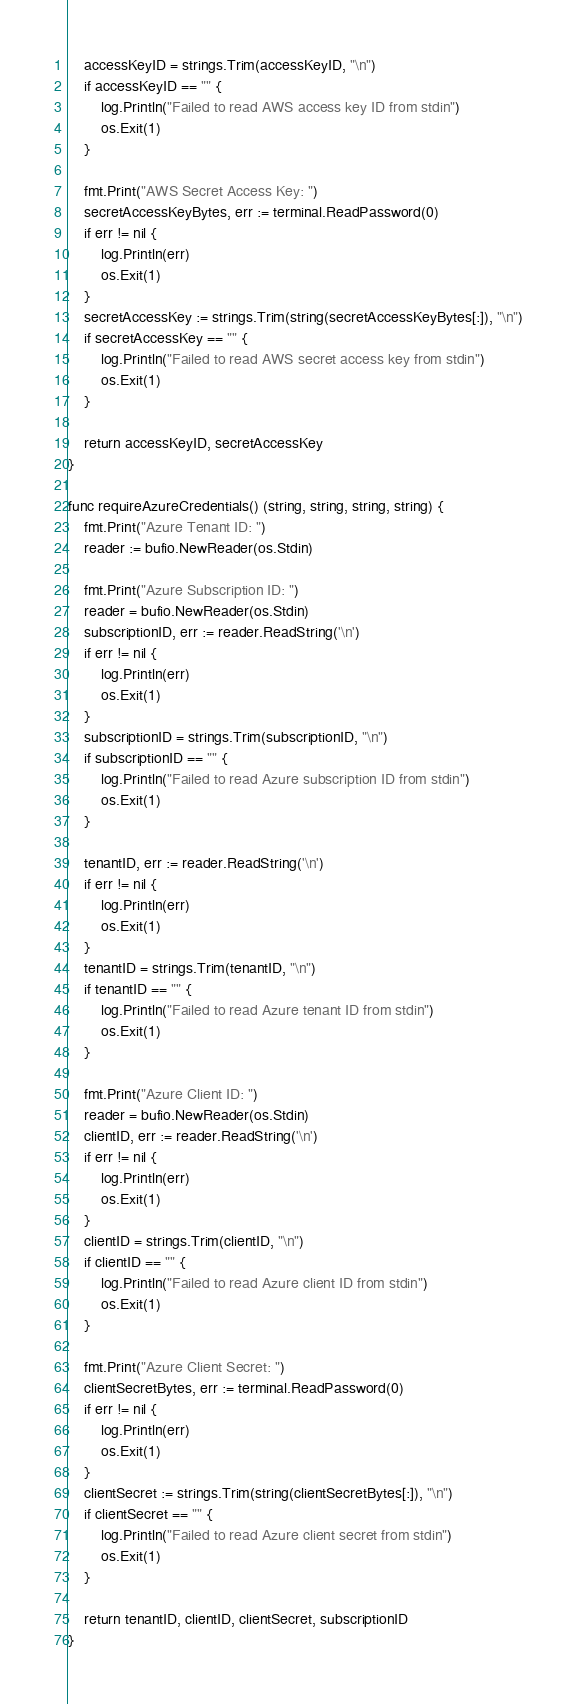Convert code to text. <code><loc_0><loc_0><loc_500><loc_500><_Go_>	accessKeyID = strings.Trim(accessKeyID, "\n")
	if accessKeyID == "" {
		log.Println("Failed to read AWS access key ID from stdin")
		os.Exit(1)
	}

	fmt.Print("AWS Secret Access Key: ")
	secretAccessKeyBytes, err := terminal.ReadPassword(0)
	if err != nil {
		log.Println(err)
		os.Exit(1)
	}
	secretAccessKey := strings.Trim(string(secretAccessKeyBytes[:]), "\n")
	if secretAccessKey == "" {
		log.Println("Failed to read AWS secret access key from stdin")
		os.Exit(1)
	}

	return accessKeyID, secretAccessKey
}

func requireAzureCredentials() (string, string, string, string) {
	fmt.Print("Azure Tenant ID: ")
	reader := bufio.NewReader(os.Stdin)

	fmt.Print("Azure Subscription ID: ")
	reader = bufio.NewReader(os.Stdin)
	subscriptionID, err := reader.ReadString('\n')
	if err != nil {
		log.Println(err)
		os.Exit(1)
	}
	subscriptionID = strings.Trim(subscriptionID, "\n")
	if subscriptionID == "" {
		log.Println("Failed to read Azure subscription ID from stdin")
		os.Exit(1)
	}

	tenantID, err := reader.ReadString('\n')
	if err != nil {
		log.Println(err)
		os.Exit(1)
	}
	tenantID = strings.Trim(tenantID, "\n")
	if tenantID == "" {
		log.Println("Failed to read Azure tenant ID from stdin")
		os.Exit(1)
	}

	fmt.Print("Azure Client ID: ")
	reader = bufio.NewReader(os.Stdin)
	clientID, err := reader.ReadString('\n')
	if err != nil {
		log.Println(err)
		os.Exit(1)
	}
	clientID = strings.Trim(clientID, "\n")
	if clientID == "" {
		log.Println("Failed to read Azure client ID from stdin")
		os.Exit(1)
	}

	fmt.Print("Azure Client Secret: ")
	clientSecretBytes, err := terminal.ReadPassword(0)
	if err != nil {
		log.Println(err)
		os.Exit(1)
	}
	clientSecret := strings.Trim(string(clientSecretBytes[:]), "\n")
	if clientSecret == "" {
		log.Println("Failed to read Azure client secret from stdin")
		os.Exit(1)
	}

	return tenantID, clientID, clientSecret, subscriptionID
}
</code> 